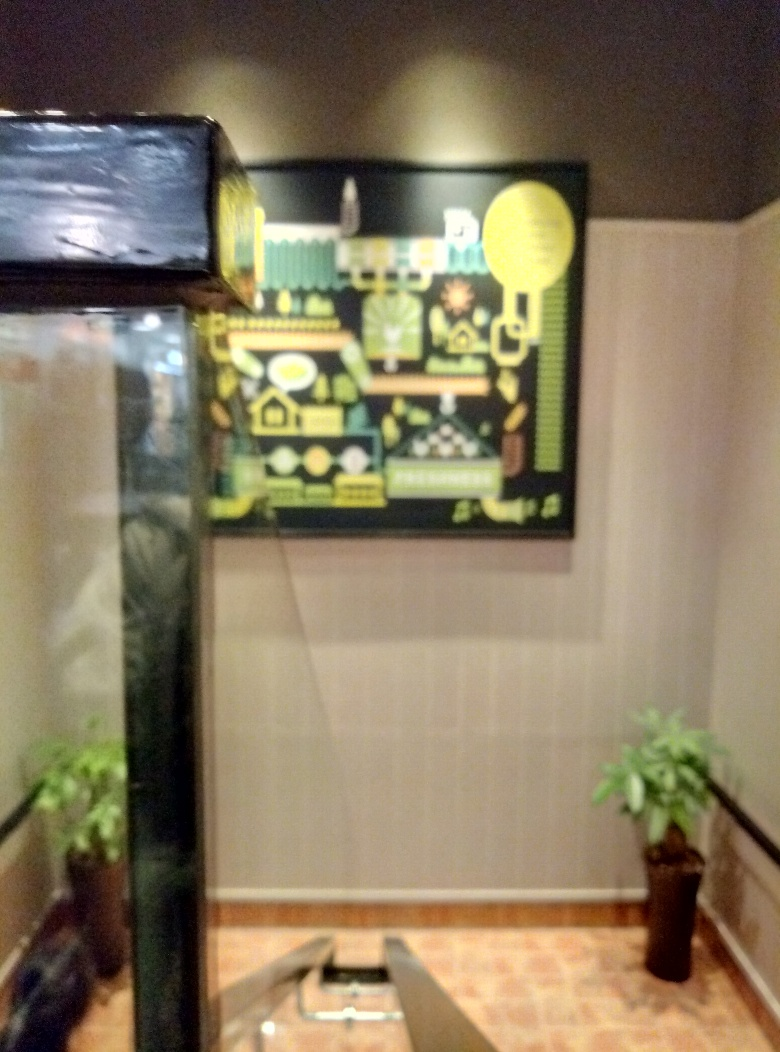Can you describe the colors in this image? Despite the blurry quality, the image contains a range of colors, mainly dark and light green tones, with hints of yellow and possibly some black or dark areas. It seems these colors could be part of an illustration or a decorative item. 